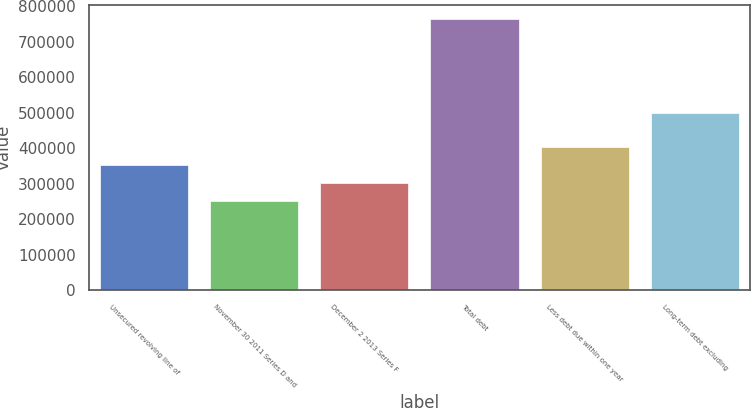Convert chart. <chart><loc_0><loc_0><loc_500><loc_500><bar_chart><fcel>Unsecured revolving line of<fcel>November 30 2011 Series D and<fcel>December 2 2013 Series F<fcel>Total debt<fcel>Less debt due within one year<fcel>Long-term debt excluding<nl><fcel>353093<fcel>250000<fcel>301547<fcel>765466<fcel>404640<fcel>500000<nl></chart> 